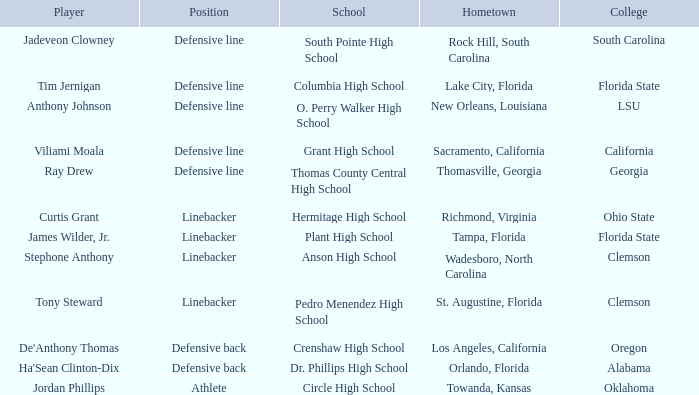From which hometown does a ray drew player come? Thomasville, Georgia. 